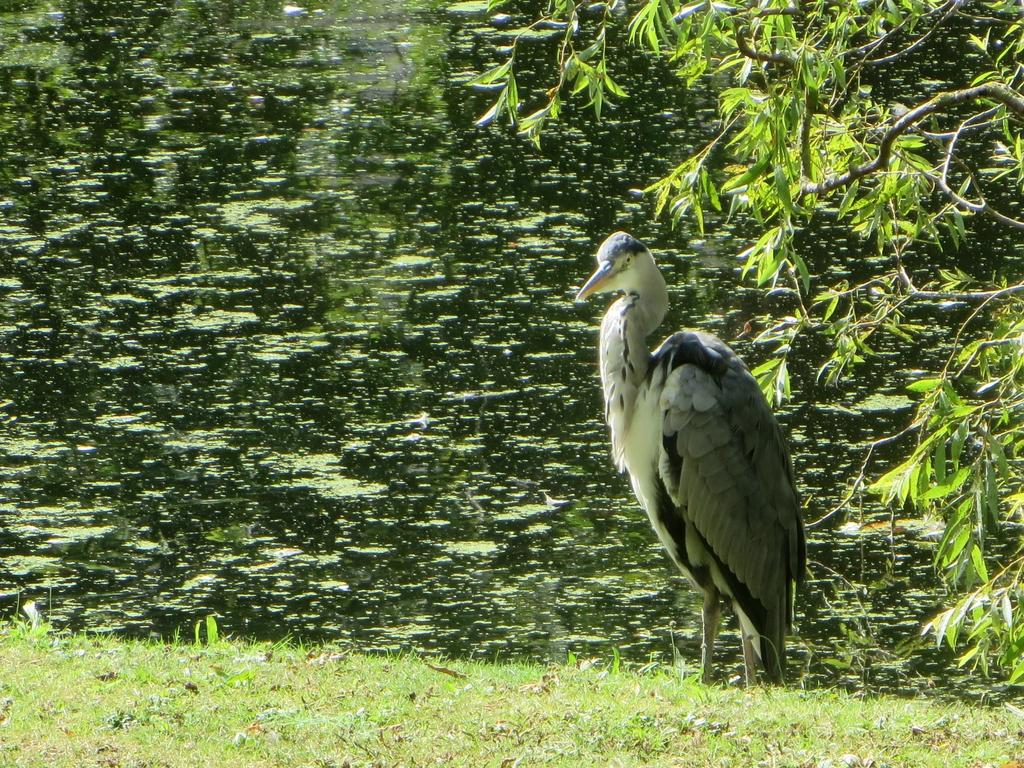What type of animal is present in the image? There is a bird in the image. What type of vegetation can be seen in the image? There is grass in the image. What natural element is also visible in the image? There is water in the image. What other type of plant material is present in the image? There are leaves in the image. How many bushes are present in the image? There is no mention of bushes in the image; only grass, water, and leaves are described. Can you tell me how the bird is planning to join the other animals in the image? There are no other animals present in the image, and the bird is not shown to be joining any group. 